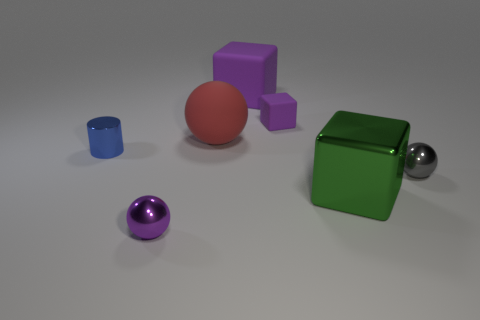Is there anything else that is the same color as the metal cylinder?
Give a very brief answer. No. Are there more big purple cubes in front of the green block than small blue rubber spheres?
Offer a very short reply. No. Do the red sphere and the green thing have the same size?
Offer a terse response. Yes. There is a gray object that is the same shape as the big red rubber object; what is it made of?
Offer a terse response. Metal. What number of purple objects are either matte blocks or metallic cylinders?
Your response must be concise. 2. There is a purple object to the left of the red object; what is its material?
Provide a succinct answer. Metal. Are there more large green shiny objects than large gray metallic blocks?
Give a very brief answer. Yes. There is a red matte thing that is on the left side of the tiny purple matte thing; is it the same shape as the purple metal thing?
Offer a very short reply. Yes. What number of things are both on the right side of the red rubber thing and behind the blue thing?
Provide a succinct answer. 2. How many other gray shiny objects have the same shape as the gray shiny thing?
Your answer should be very brief. 0. 